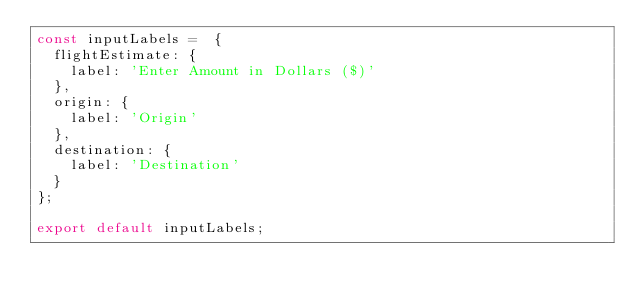Convert code to text. <code><loc_0><loc_0><loc_500><loc_500><_JavaScript_>const inputLabels =  {
  flightEstimate: {
    label: 'Enter Amount in Dollars ($)'
  },
  origin: {
    label: 'Origin'
  },
  destination: {
    label: 'Destination'
  }
};

export default inputLabels;
</code> 